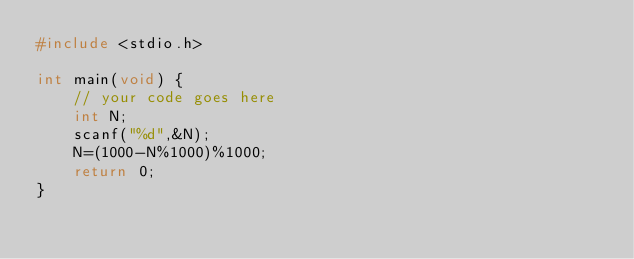<code> <loc_0><loc_0><loc_500><loc_500><_C_>#include <stdio.h>

int main(void) {
	// your code goes here
	int N;
	scanf("%d",&N);
	N=(1000-N%1000)%1000;
	return 0;
}
</code> 